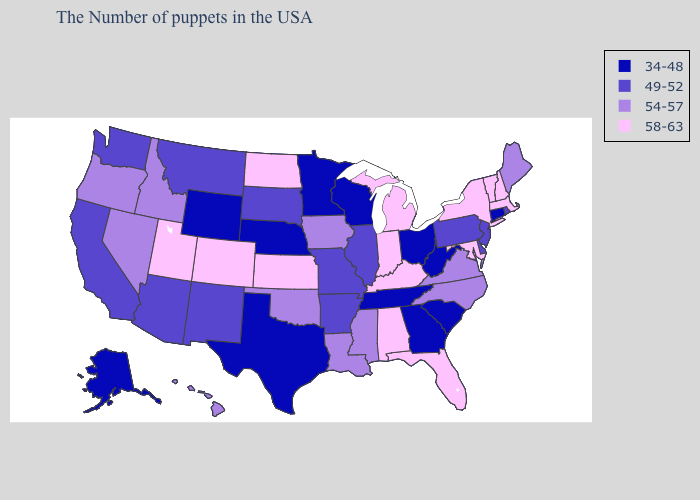Among the states that border Indiana , which have the highest value?
Write a very short answer. Michigan, Kentucky. What is the lowest value in the MidWest?
Quick response, please. 34-48. What is the value of Kentucky?
Quick response, please. 58-63. Name the states that have a value in the range 54-57?
Quick response, please. Maine, Virginia, North Carolina, Mississippi, Louisiana, Iowa, Oklahoma, Idaho, Nevada, Oregon, Hawaii. What is the highest value in the West ?
Concise answer only. 58-63. Is the legend a continuous bar?
Be succinct. No. Name the states that have a value in the range 54-57?
Keep it brief. Maine, Virginia, North Carolina, Mississippi, Louisiana, Iowa, Oklahoma, Idaho, Nevada, Oregon, Hawaii. Is the legend a continuous bar?
Quick response, please. No. Among the states that border Georgia , which have the lowest value?
Be succinct. South Carolina, Tennessee. Among the states that border North Carolina , which have the lowest value?
Quick response, please. South Carolina, Georgia, Tennessee. Does Illinois have the highest value in the MidWest?
Answer briefly. No. What is the value of Nebraska?
Write a very short answer. 34-48. Name the states that have a value in the range 58-63?
Answer briefly. Massachusetts, New Hampshire, Vermont, New York, Maryland, Florida, Michigan, Kentucky, Indiana, Alabama, Kansas, North Dakota, Colorado, Utah. What is the value of Arkansas?
Keep it brief. 49-52. 